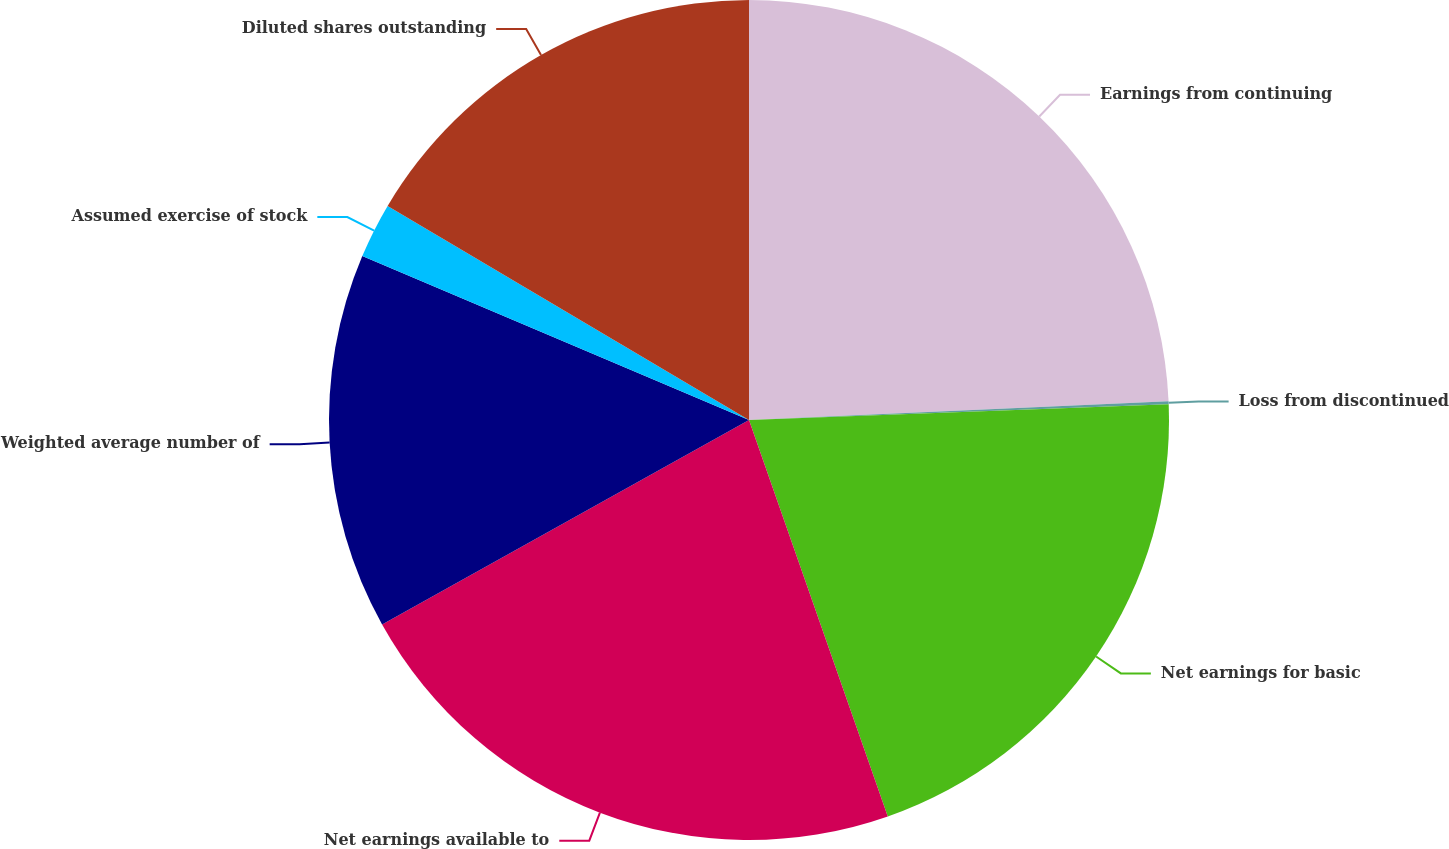Convert chart. <chart><loc_0><loc_0><loc_500><loc_500><pie_chart><fcel>Earnings from continuing<fcel>Loss from discontinued<fcel>Net earnings for basic<fcel>Net earnings available to<fcel>Weighted average number of<fcel>Assumed exercise of stock<fcel>Diluted shares outstanding<nl><fcel>24.29%<fcel>0.11%<fcel>20.24%<fcel>22.27%<fcel>14.47%<fcel>2.13%<fcel>16.49%<nl></chart> 